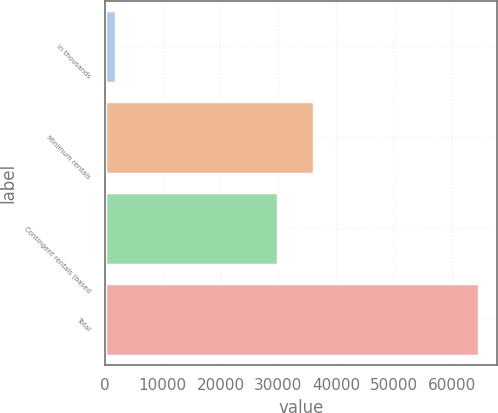<chart> <loc_0><loc_0><loc_500><loc_500><bar_chart><fcel>in thousands<fcel>Minimum rentals<fcel>Contingent rentals (based<fcel>Total<nl><fcel>2011<fcel>36139.2<fcel>29882<fcel>64583<nl></chart> 